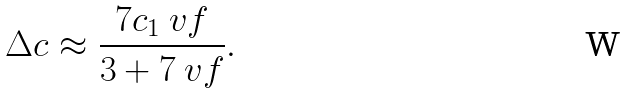<formula> <loc_0><loc_0><loc_500><loc_500>\Delta c \approx \frac { 7 c _ { 1 } \ v f } { 3 + 7 \ v f } .</formula> 